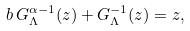Convert formula to latex. <formula><loc_0><loc_0><loc_500><loc_500>b \, G _ { \Lambda } ^ { \alpha - 1 } ( z ) + G _ { \Lambda } ^ { - 1 } ( z ) = z ,</formula> 